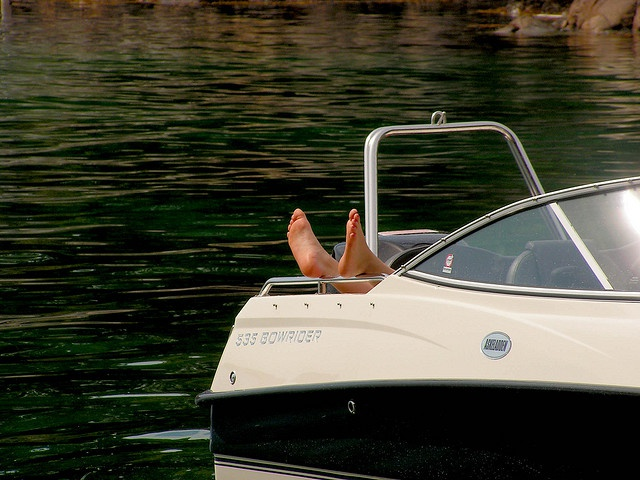Describe the objects in this image and their specific colors. I can see boat in olive, black, lightgray, gray, and darkgray tones and people in olive, brown, salmon, and maroon tones in this image. 